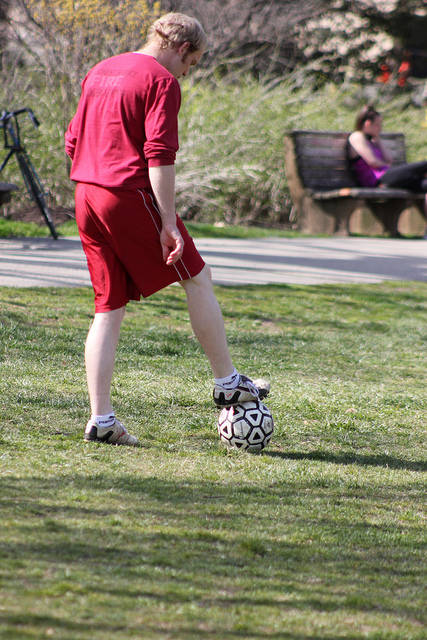Read and extract the text from this image. FIRE 